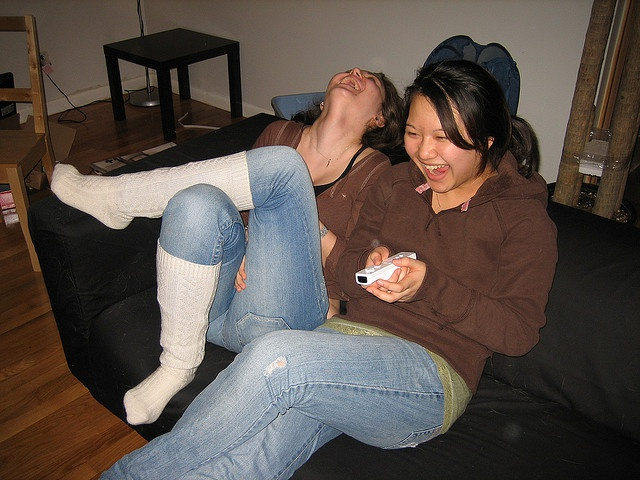Describe the objects in this image and their specific colors. I can see people in black, maroon, darkgray, and gray tones, couch in black, darkgray, maroon, and gray tones, people in black, darkgray, lightgray, gray, and tan tones, chair in black, maroon, and gray tones, and remote in black, white, lightpink, and darkgray tones in this image. 